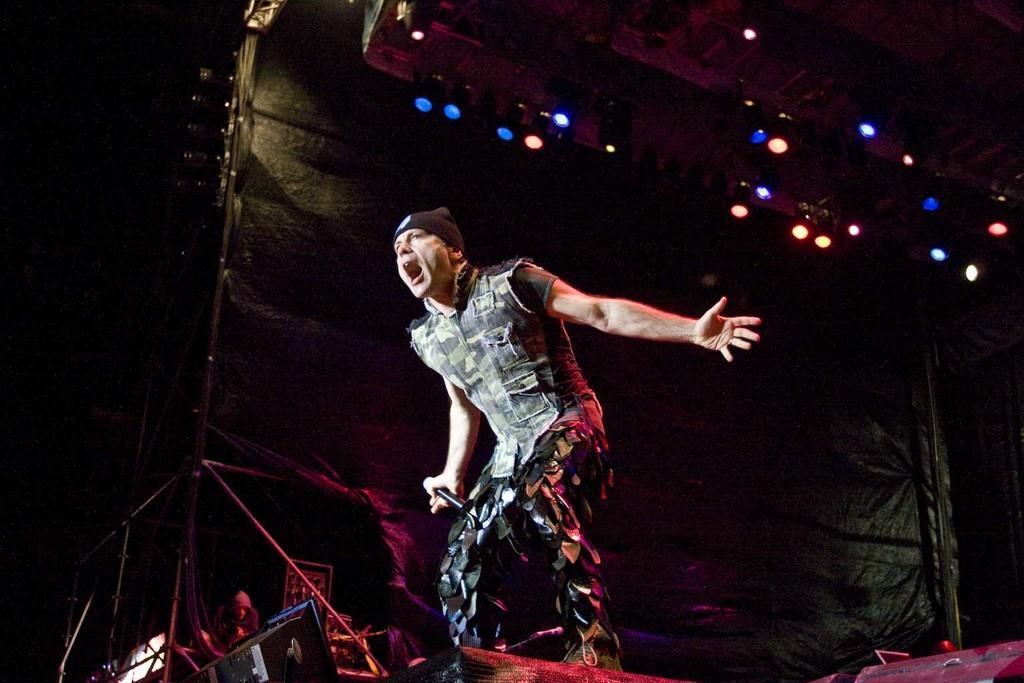In one or two sentences, can you explain what this image depicts? There is a man standing and holding a microphone. In the background it is dark and we can see person,rods and electrical devices. At the top we can see lights. 